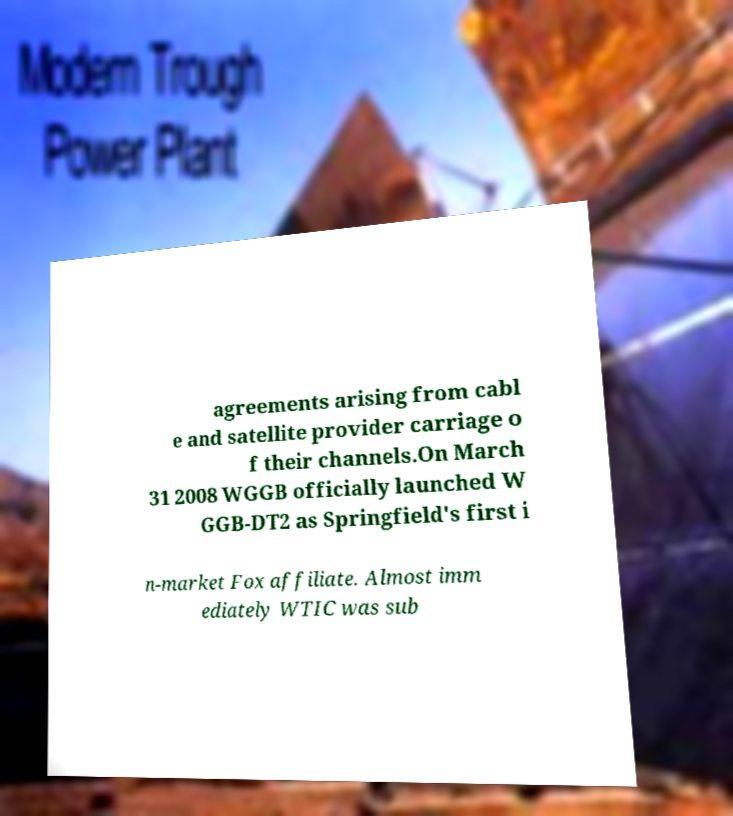Can you accurately transcribe the text from the provided image for me? agreements arising from cabl e and satellite provider carriage o f their channels.On March 31 2008 WGGB officially launched W GGB-DT2 as Springfield's first i n-market Fox affiliate. Almost imm ediately WTIC was sub 